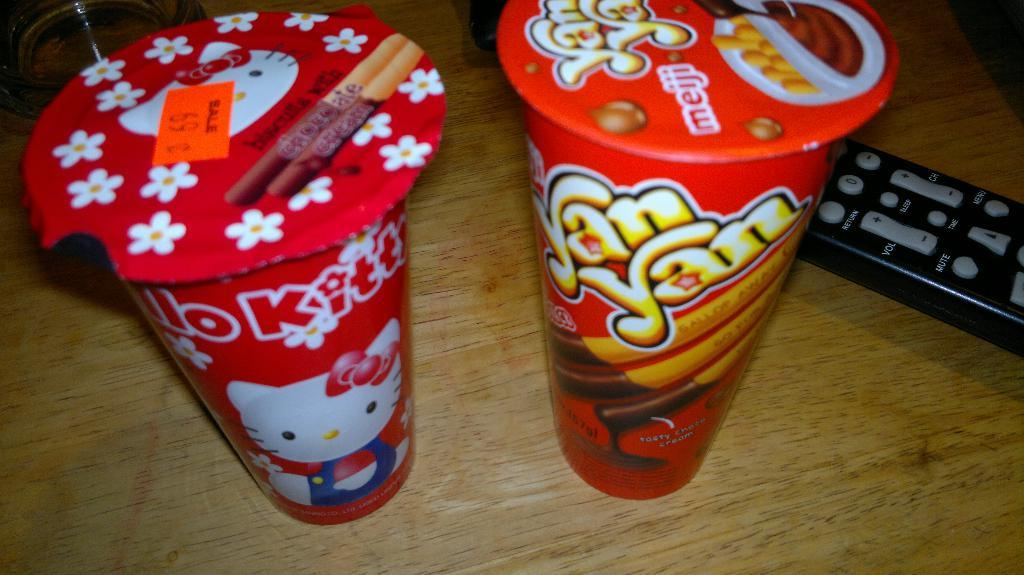<image>
Relay a brief, clear account of the picture shown. canister of meiji yanyan and one with a kitten on it next to a black remote 